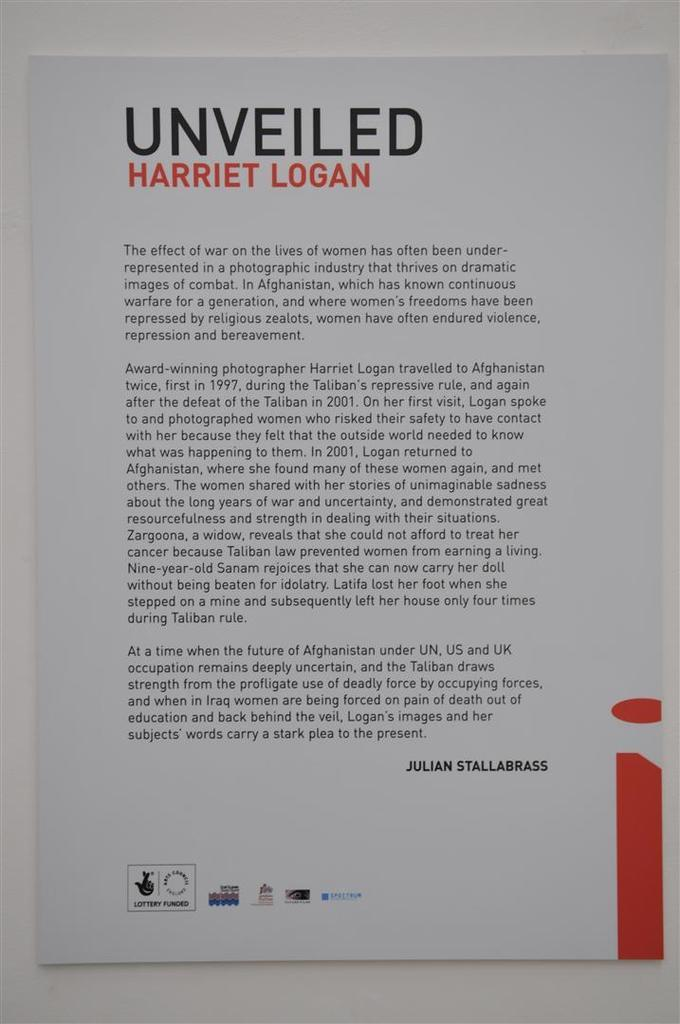Provide a one-sentence caption for the provided image. A small poster that says Unveiled Harriet Logan on it. 